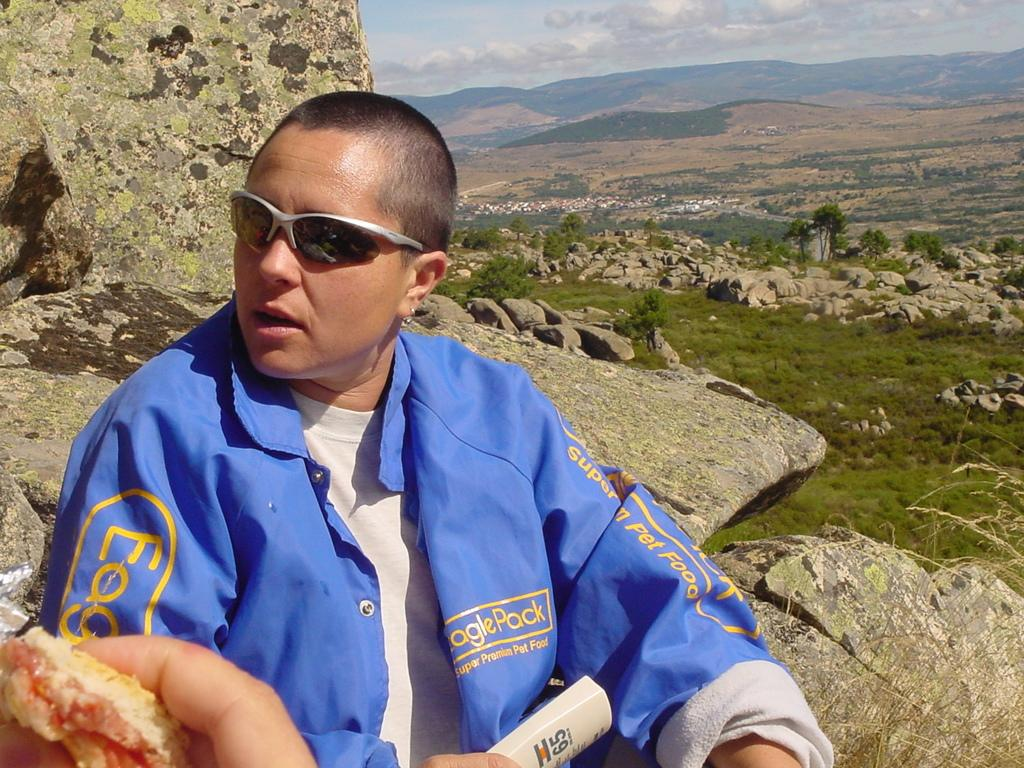Who is in the picture? There is a man in the picture. What is the man wearing? The man is wearing a blue shirt and black sunglasses. Where is the man sitting? The man is sitting on a rock mountain. What is the man doing in the picture? The man is giving a pose. What can be seen in the background of the picture? There are trees and a mountain visible in the background. What type of picture is the man holding in the image? There is no picture visible in the image; the man is sitting on a rock mountain and giving a pose. 